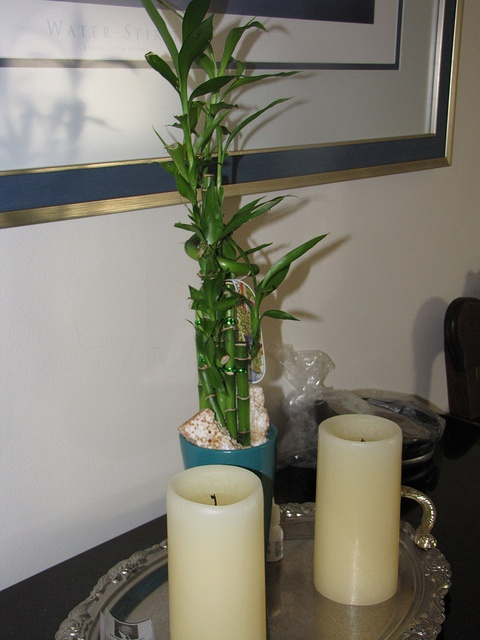Describe the objects in this image and their specific colors. I can see potted plant in darkgray, black, and darkgreen tones and vase in darkgray, teal, and black tones in this image. 